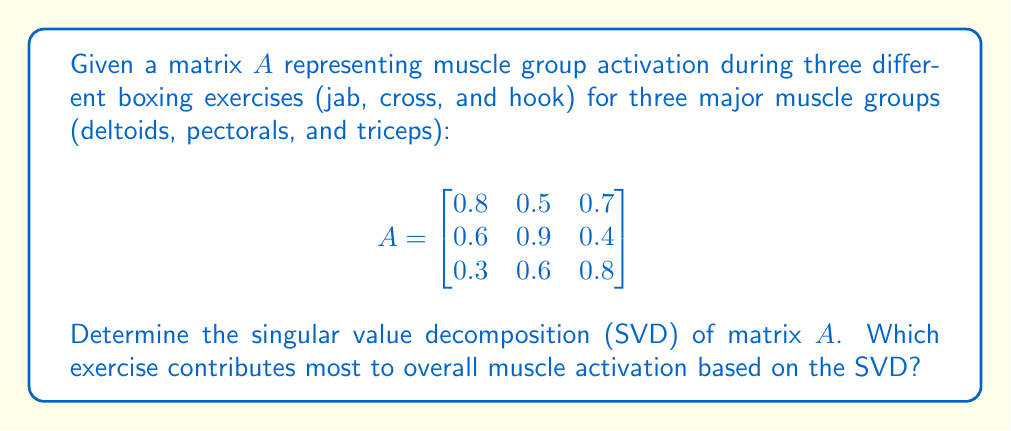Show me your answer to this math problem. To find the singular value decomposition (SVD) of matrix $A$, we need to find matrices $U$, $\Sigma$, and $V^T$ such that $A = U\Sigma V^T$.

Step 1: Calculate $A^TA$ and $AA^T$:

$$A^TA = \begin{bmatrix}
1.29 & 1.31 & 1.13 \\
1.31 & 1.62 & 1.15 \\
1.13 & 1.15 & 1.33
\end{bmatrix}$$

$$AA^T = \begin{bmatrix}
1.38 & 1.19 & 1.01 \\
1.19 & 1.37 & 0.90 \\
1.01 & 0.90 & 1.09
\end{bmatrix}$$

Step 2: Find eigenvalues of $A^TA$ (same as singular values squared):
Solving $\det(A^TA - \lambda I) = 0$, we get:
$\lambda_1 \approx 3.6921$, $\lambda_2 \approx 0.4079$, $\lambda_3 \approx 0.1000$

Step 3: Calculate singular values:
$\sigma_1 = \sqrt{3.6921} \approx 1.9215$
$\sigma_2 = \sqrt{0.4079} \approx 0.6387$
$\sigma_3 = \sqrt{0.1000} \approx 0.3162$

Step 4: Find eigenvectors of $A^TA$ (columns of $V$):
$$V \approx \begin{bmatrix}
-0.5657 & 0.7682 & 0.3012 \\
-0.6533 & -0.5789 & -0.4880 \\
-0.5033 & -0.2737 & 0.8194
\end{bmatrix}$$

Step 5: Calculate $U$ using $AV = U\Sigma$:
$$U \approx \begin{bmatrix}
-0.6201 & 0.7448 & -0.2449 \\
-0.6458 & -0.6359 & 0.4231 \\
-0.4453 & -0.2019 & -0.8724
\end{bmatrix}$$

Step 6: Construct $\Sigma$:
$$\Sigma = \begin{bmatrix}
1.9215 & 0 & 0 \\
0 & 0.6387 & 0 \\
0 & 0 & 0.3162
\end{bmatrix}$$

The exercise that contributes most to overall muscle activation is represented by the first column of $V$, which corresponds to the largest singular value. The absolute values of this column are [0.5657, 0.6533, 0.5033], indicating that the second exercise (cross) contributes most to overall muscle activation.
Answer: $A = U\Sigma V^T$, where:
$U \approx [-0.6201, 0.7448, -0.2449; -0.6458, -0.6359, 0.4231; -0.4453, -0.2019, -0.8724]$
$\Sigma \approx \text{diag}(1.9215, 0.6387, 0.3162)$
$V^T \approx [-0.5657, -0.6533, -0.5033; 0.7682, -0.5789, -0.2737; 0.3012, -0.4880, 0.8194]$
Cross contributes most to overall muscle activation. 